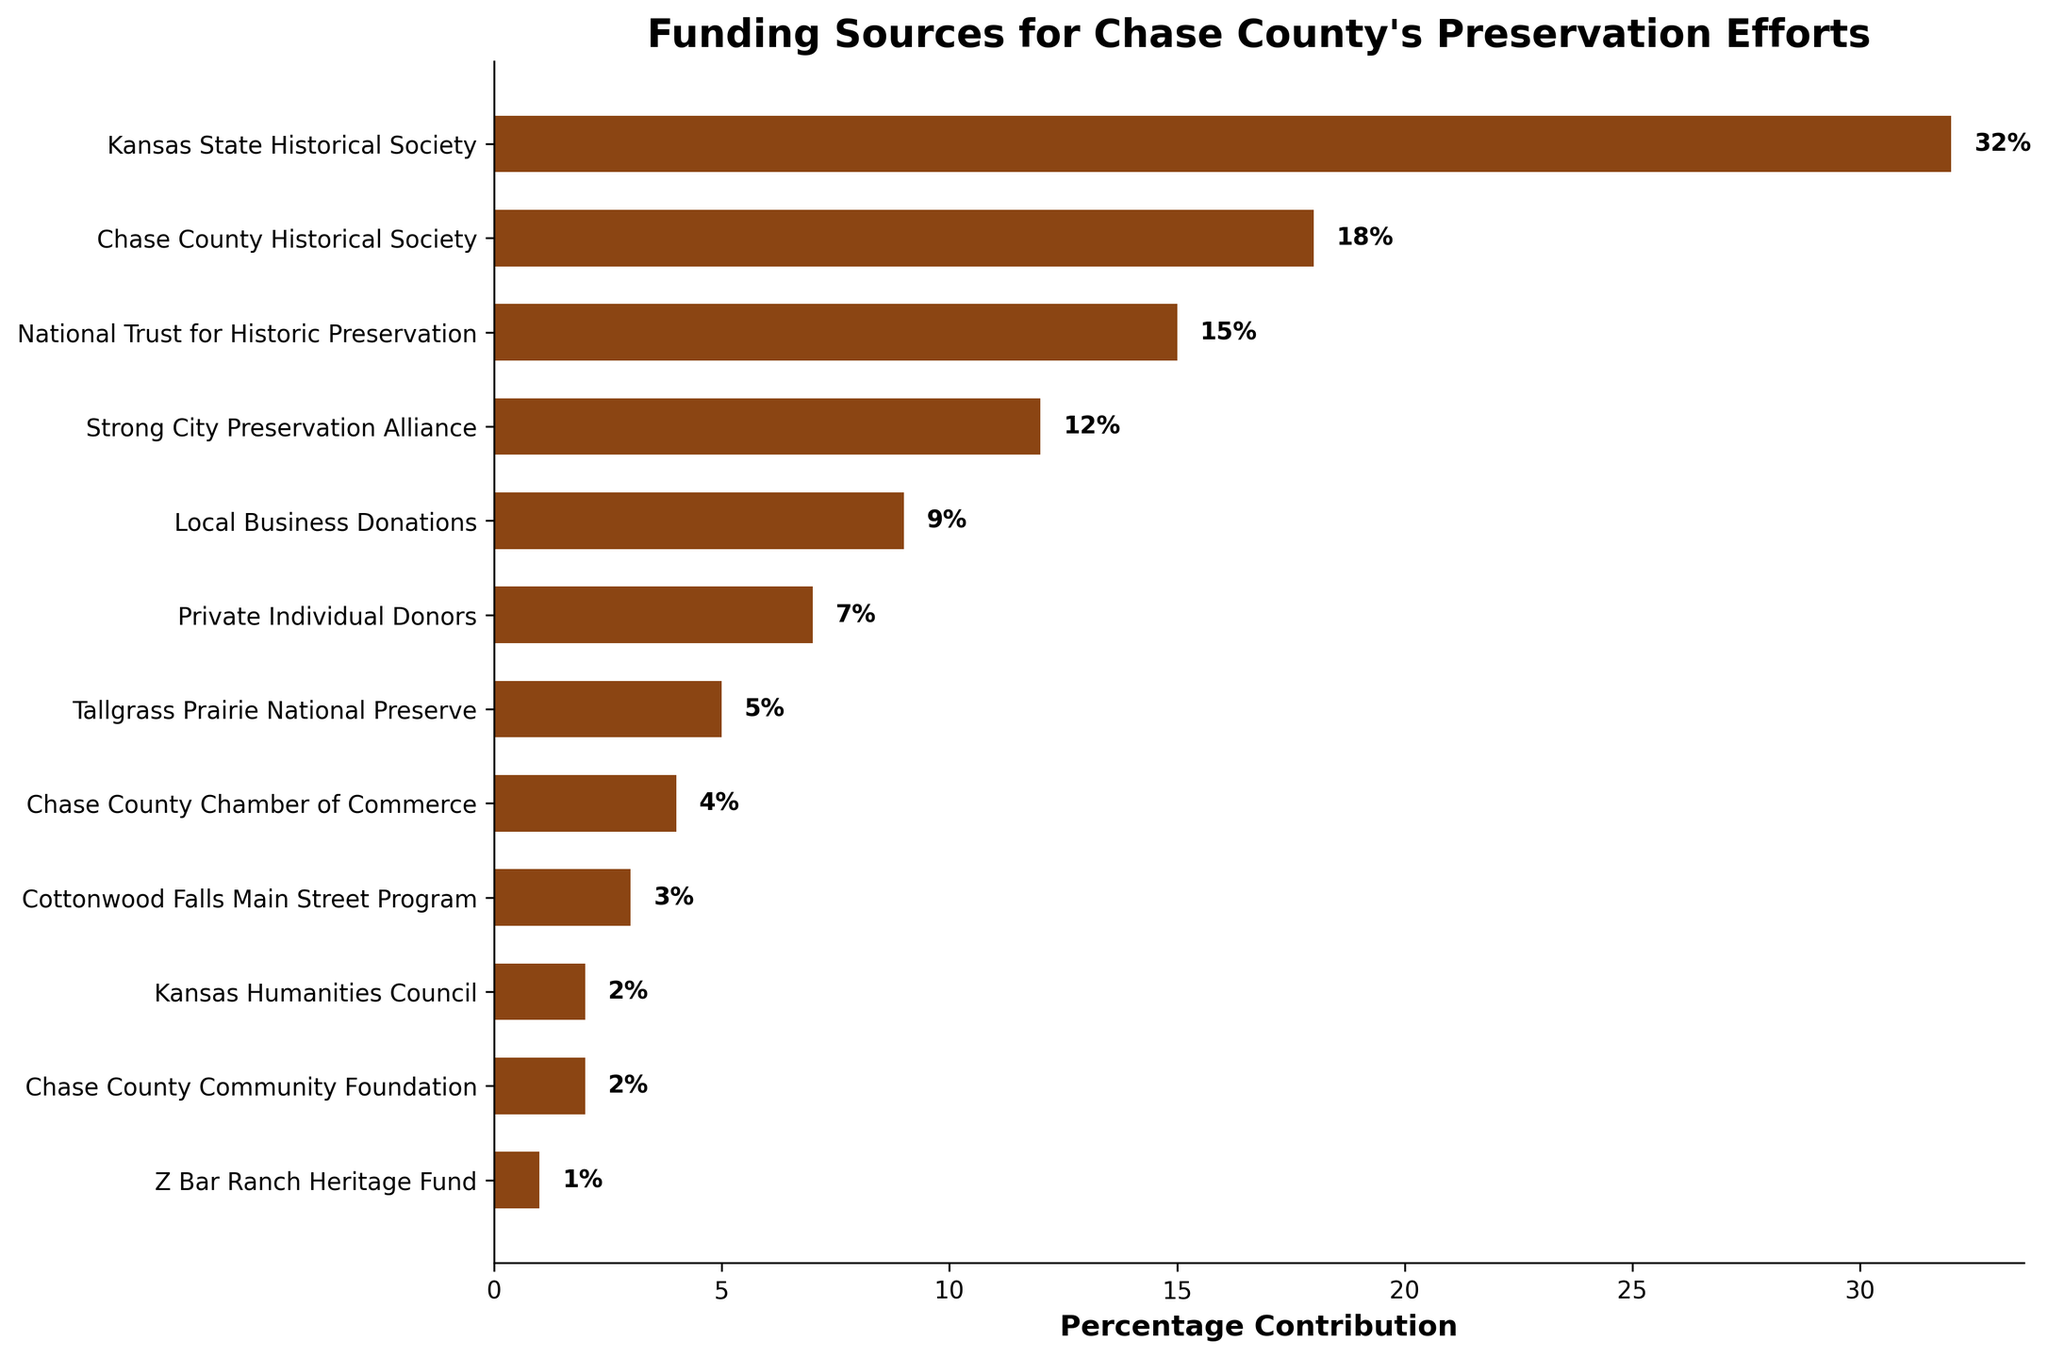What's the primary funding source for Chase County's preservation efforts? The primary funding source is determined by looking at the bar with the highest percentage contribution. The Kansas State Historical Society has the highest contribution at 32%.
Answer: Kansas State Historical Society Which organization has a 15% contribution to Chase County's preservation efforts? By referring to the bar with the label showing a 15% contribution, we see that the National Trust for Historic Preservation has a 15% contribution.
Answer: National Trust for Historic Preservation How much more does the Kansas State Historical Society contribute compared to the Chase County Chamber of Commerce? The Kansas State Historical Society contributes 32%, and the Chase County Chamber of Commerce contributes 4%. The difference is 32% - 4%, which equals 28%.
Answer: 28% What is the combined contribution of the Strong City Preservation Alliance and the Local Business Donations? The Strong City Preservation Alliance contributes 12%, and the Local Business Donations contribute 9%. Their combined contribution is 12% + 9%, which equals 21%.
Answer: 21% Identify the funding sources that contribute less than 5%. By looking at the bars with contributions less than 5%, we identify Tallgrass Prairie National Preserve (5%), Chase County Chamber of Commerce (4%), Cottonwood Falls Main Street Program (3%), Kansas Humanities Council (2%), Chase County Community Foundation (2%), and Z Bar Ranch Heritage Fund (1%).
Answer: Tallgrass Prairie National Preserve, Chase County Chamber of Commerce, Cottonwood Falls Main Street Program, Kansas Humanities Council, Chase County Community Foundation, Z Bar Ranch Heritage Fund What is the second highest percentage contribution and which organization does it belong to? The second highest percentage contribution is identified by finding the next highest bar after the primary source. The Chase County Historical Society has the second highest contribution at 18%.
Answer: Chase County Historical Society Is the contribution from Private Individual Donors greater than that from the Tallgrass Prairie National Preserve? Private Individual Donors contribute 7%, whereas the Tallgrass Prairie National Preserve contributes 5%. Since 7% is greater than 5%, the contribution from Private Individual Donors is indeed greater.
Answer: Yes Sum the contributions of all organizations that individually contribute less than 10%. Contributions less than 10% are from Local Business Donations (9%), Private Individual Donors (7%), Tallgrass Prairie National Preserve (5%), Chase County Chamber of Commerce (4%), Cottonwood Falls Main Street Program (3%), Kansas Humanities Council (2%), Chase County Community Foundation (2%), and Z Bar Ranch Heritage Fund (1%). The sum is 9% + 7% + 5% + 4% + 3% + 2% + 2% + 1% = 33%.
Answer: 33% Which funding sources contribute more than the average contribution of all sources? First, calculate the average by summing all contributions (32 + 18 + 15 + 12 + 9 + 7 + 5 + 4 + 3 + 2 + 2 + 1 = 110) and dividing by the number of sources (110 / 12 ≈ 9.17%). Sources contributing more than the average (9.17%) are Kansas State Historical Society (32%), Chase County Historical Society (18%), National Trust for Historic Preservation (15%), and Strong City Preservation Alliance (12%).
Answer: Kansas State Historical Society, Chase County Historical Society, National Trust for Historic Preservation, Strong City Preservation Alliance 